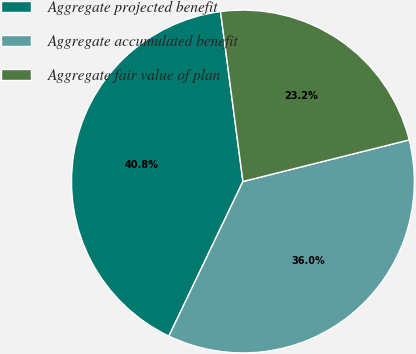Convert chart. <chart><loc_0><loc_0><loc_500><loc_500><pie_chart><fcel>Aggregate projected benefit<fcel>Aggregate accumulated benefit<fcel>Aggregate fair value of plan<nl><fcel>40.8%<fcel>36.01%<fcel>23.18%<nl></chart> 